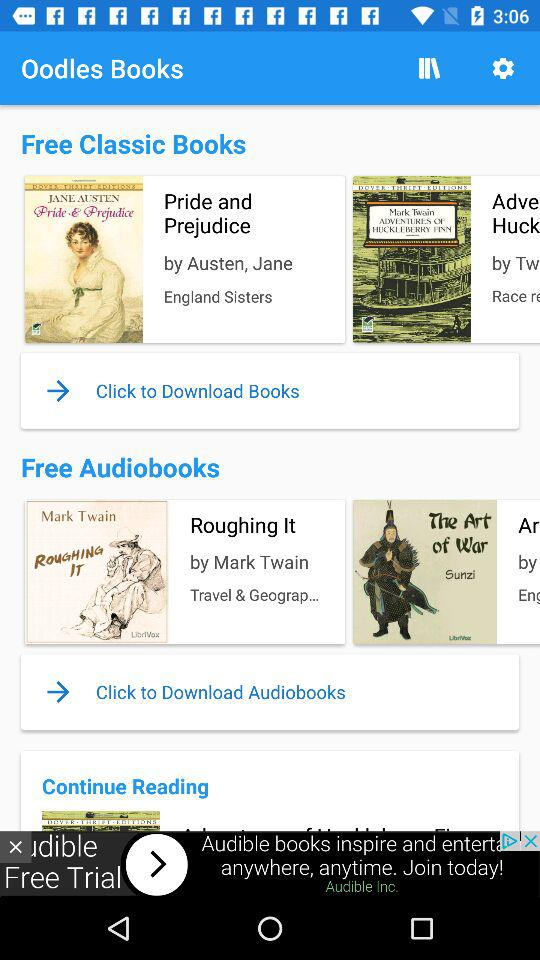How many books are in the Free Classic Books section that are not written by Jane Austen?
Answer the question using a single word or phrase. 1 